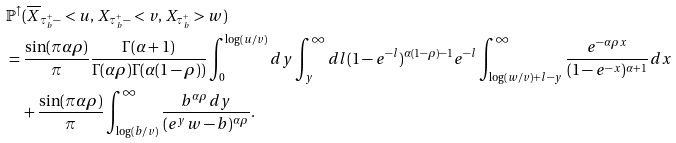Convert formula to latex. <formula><loc_0><loc_0><loc_500><loc_500>& \mathbb { P } ^ { \uparrow } ( \overline { X } _ { \tau ^ { + } _ { b } - } < u , \, X _ { \tau ^ { + } _ { b } - } < v , \, X _ { \tau ^ { + } _ { b } } > w ) \\ & = \frac { \sin ( \pi \alpha \rho ) } { \pi } \frac { \Gamma ( \alpha + 1 ) } { \Gamma ( \alpha \rho ) \Gamma ( \alpha ( 1 - \rho ) ) } \int _ { 0 } ^ { \log ( u / v ) } d y \int _ { y } ^ { \infty } d l ( 1 - e ^ { - l } ) ^ { \alpha ( 1 - \rho ) - 1 } e ^ { - l } \int ^ { \infty } _ { \log ( w / v ) + l - y } \frac { e ^ { - \alpha \rho x } } { ( 1 - e ^ { - x } ) ^ { \alpha + 1 } } d x \\ & \quad + \frac { \sin ( \pi \alpha \rho ) } { \pi } \int _ { \log ( b / v ) } ^ { \infty } \frac { b ^ { \alpha \rho } d y } { ( e ^ { y } w - b ) ^ { \alpha \rho } } .</formula> 